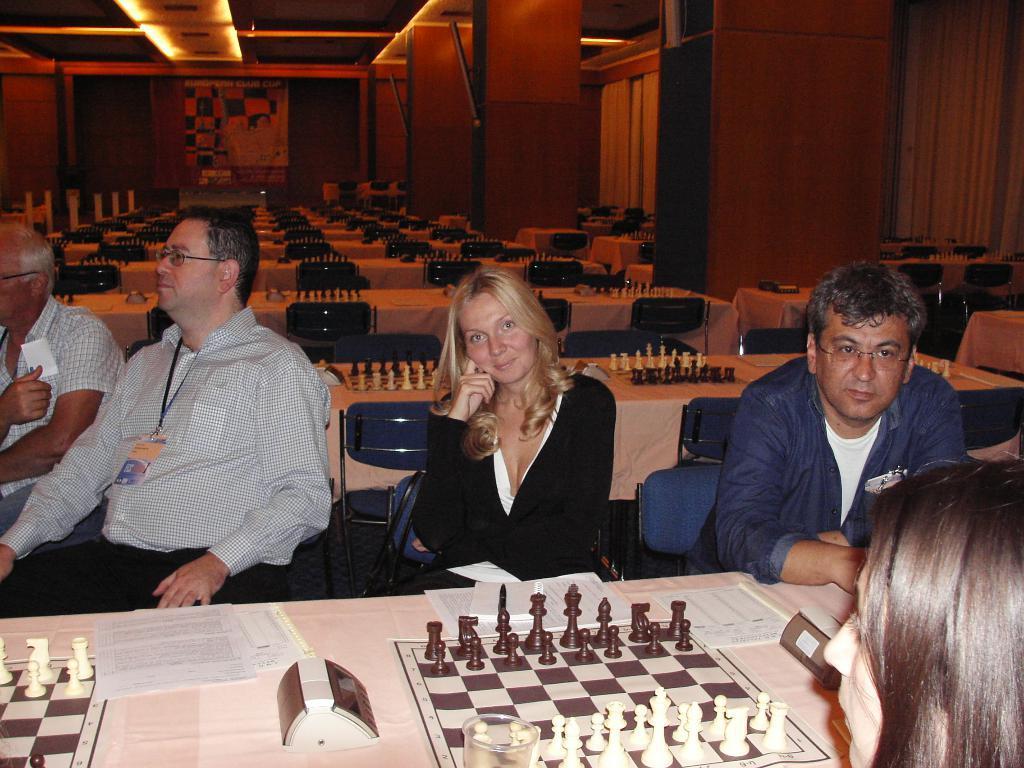Could you give a brief overview of what you see in this image? In this image we can see a group of people sitting on the chairs beside a table containing some papers and the chess boards with some coins on it. On the backside we can see a group of chairs and some tables containing the chess boards on them. We can also see some windows with curtains and a roof with some ceiling lights. 